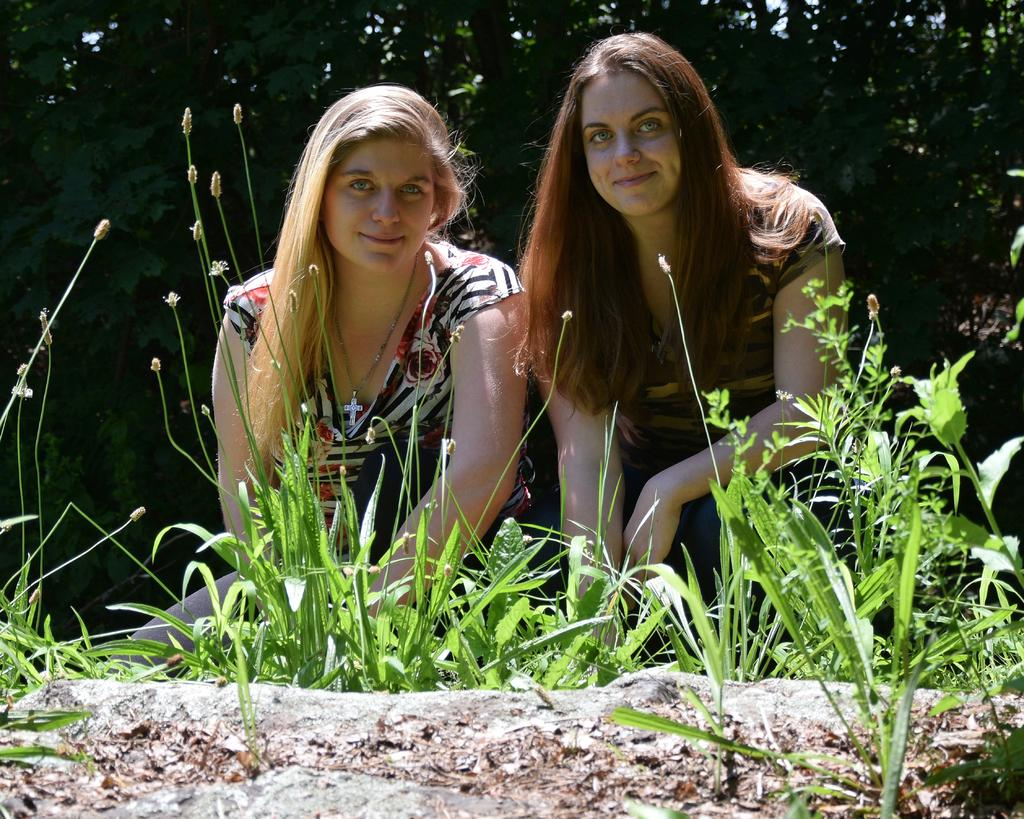How many people are in the image? There are two women in the image. What are the expressions on the women's faces? Both women are smiling in the image. What type of ground is visible in the image? There is grass and plants on the ground in the image. What can be seen in the background of the image? There are trees in the background of the image. Can you tell me how many birds are touching the insurance policy in the image? There are no birds or insurance policies present in the image. 